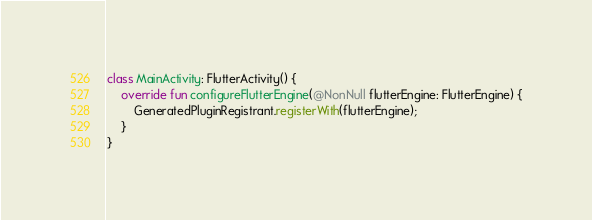<code> <loc_0><loc_0><loc_500><loc_500><_Kotlin_>class MainActivity: FlutterActivity() {
    override fun configureFlutterEngine(@NonNull flutterEngine: FlutterEngine) {
        GeneratedPluginRegistrant.registerWith(flutterEngine);
    }
}
</code> 